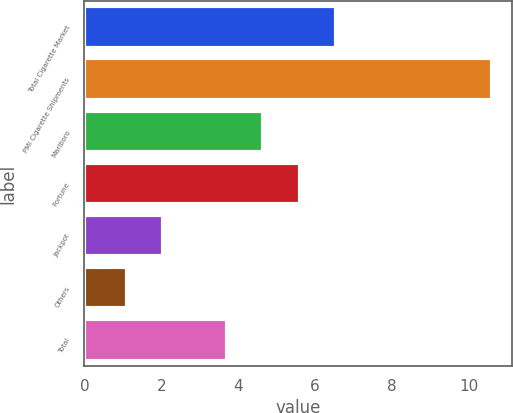Convert chart. <chart><loc_0><loc_0><loc_500><loc_500><bar_chart><fcel>Total Cigarette Market<fcel>PMI Cigarette Shipments<fcel>Marlboro<fcel>Fortune<fcel>Jackpot<fcel>Others<fcel>Total<nl><fcel>6.55<fcel>10.6<fcel>4.65<fcel>5.6<fcel>2.05<fcel>1.1<fcel>3.7<nl></chart> 